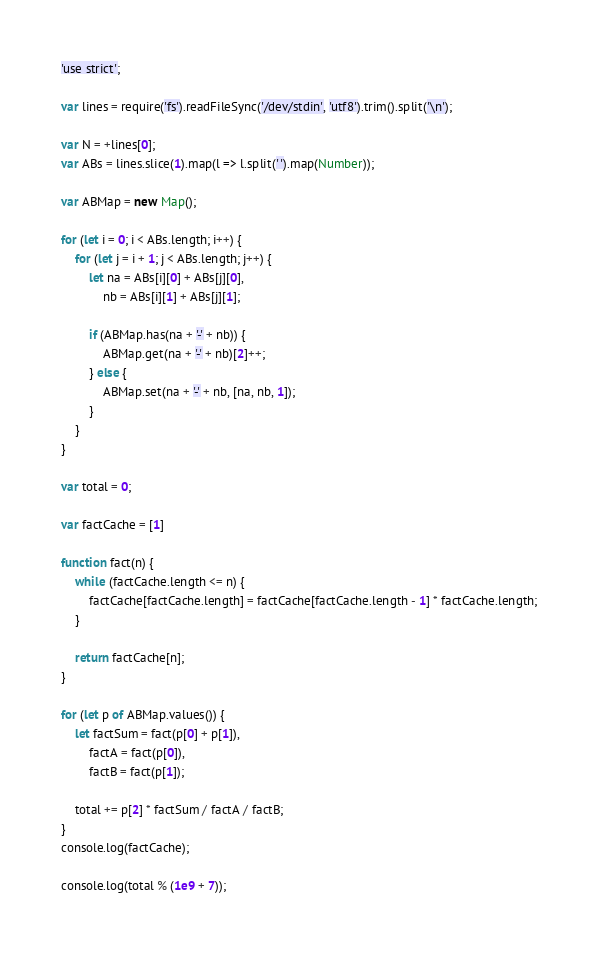<code> <loc_0><loc_0><loc_500><loc_500><_JavaScript_>'use strict';

var lines = require('fs').readFileSync('/dev/stdin', 'utf8').trim().split('\n');

var N = +lines[0];
var ABs = lines.slice(1).map(l => l.split(' ').map(Number));

var ABMap = new Map();

for (let i = 0; i < ABs.length; i++) {
    for (let j = i + 1; j < ABs.length; j++) {
        let na = ABs[i][0] + ABs[j][0],
            nb = ABs[i][1] + ABs[j][1];

        if (ABMap.has(na + '-' + nb)) {
            ABMap.get(na + '-' + nb)[2]++;
        } else {
            ABMap.set(na + '-' + nb, [na, nb, 1]);
        }
    }
}

var total = 0;

var factCache = [1]

function fact(n) {
    while (factCache.length <= n) {
        factCache[factCache.length] = factCache[factCache.length - 1] * factCache.length;
    }

    return factCache[n];
}

for (let p of ABMap.values()) {
    let factSum = fact(p[0] + p[1]),
        factA = fact(p[0]),
        factB = fact(p[1]);

    total += p[2] * factSum / factA / factB;
}
console.log(factCache);

console.log(total % (1e9 + 7));
</code> 